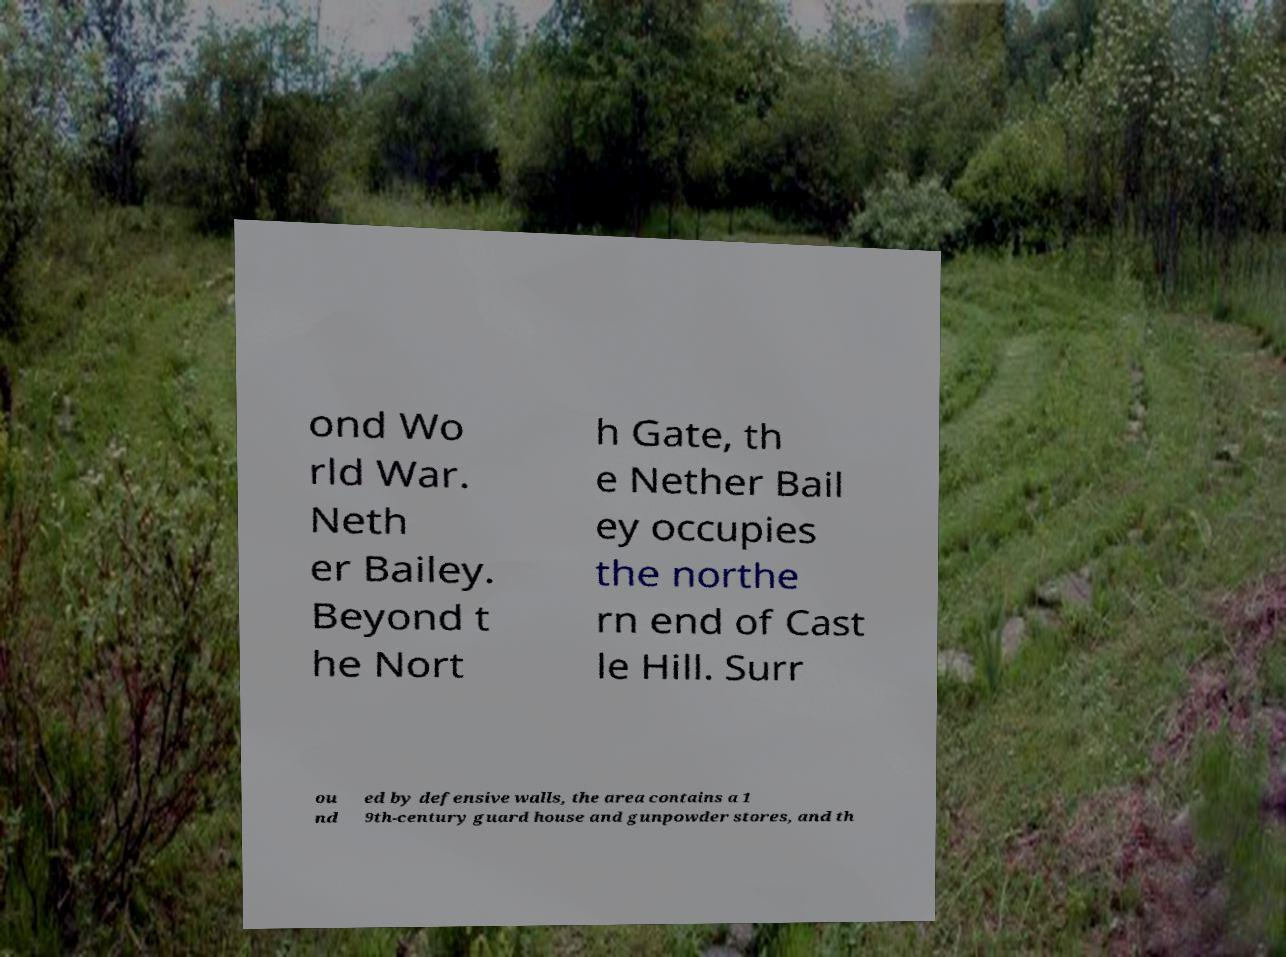Can you read and provide the text displayed in the image?This photo seems to have some interesting text. Can you extract and type it out for me? ond Wo rld War. Neth er Bailey. Beyond t he Nort h Gate, th e Nether Bail ey occupies the northe rn end of Cast le Hill. Surr ou nd ed by defensive walls, the area contains a 1 9th-century guard house and gunpowder stores, and th 